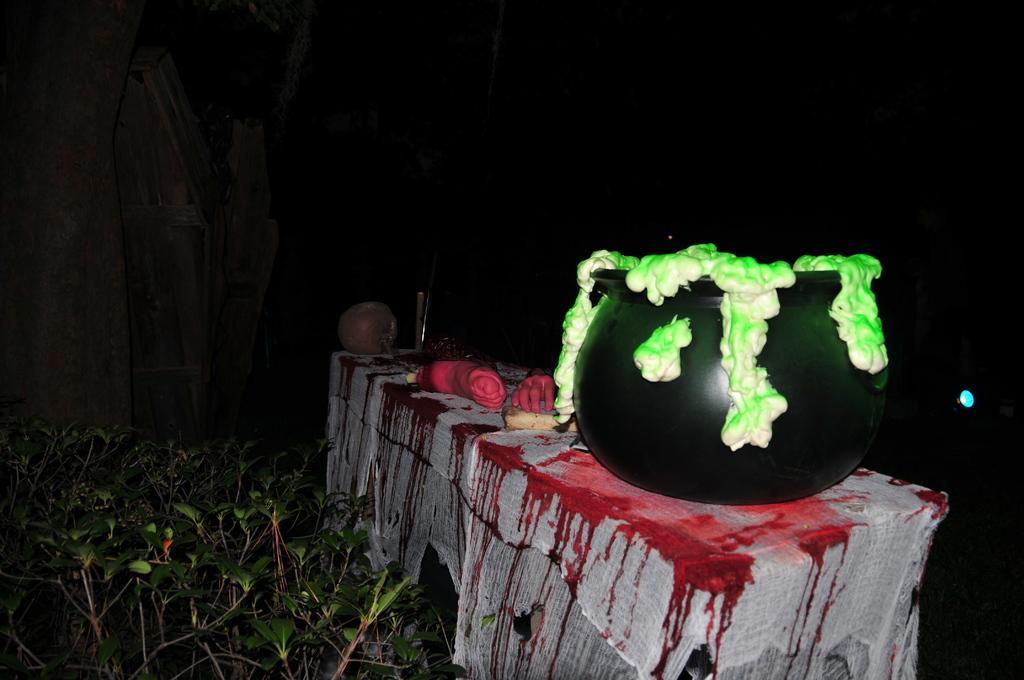Describe this image in one or two sentences. In this image, we can see a table covered with cloth. Here we can see few objects are placed on the table. On the left side bottom, we can see plants. Background we can see tree trunk, wooden object and dark view. 